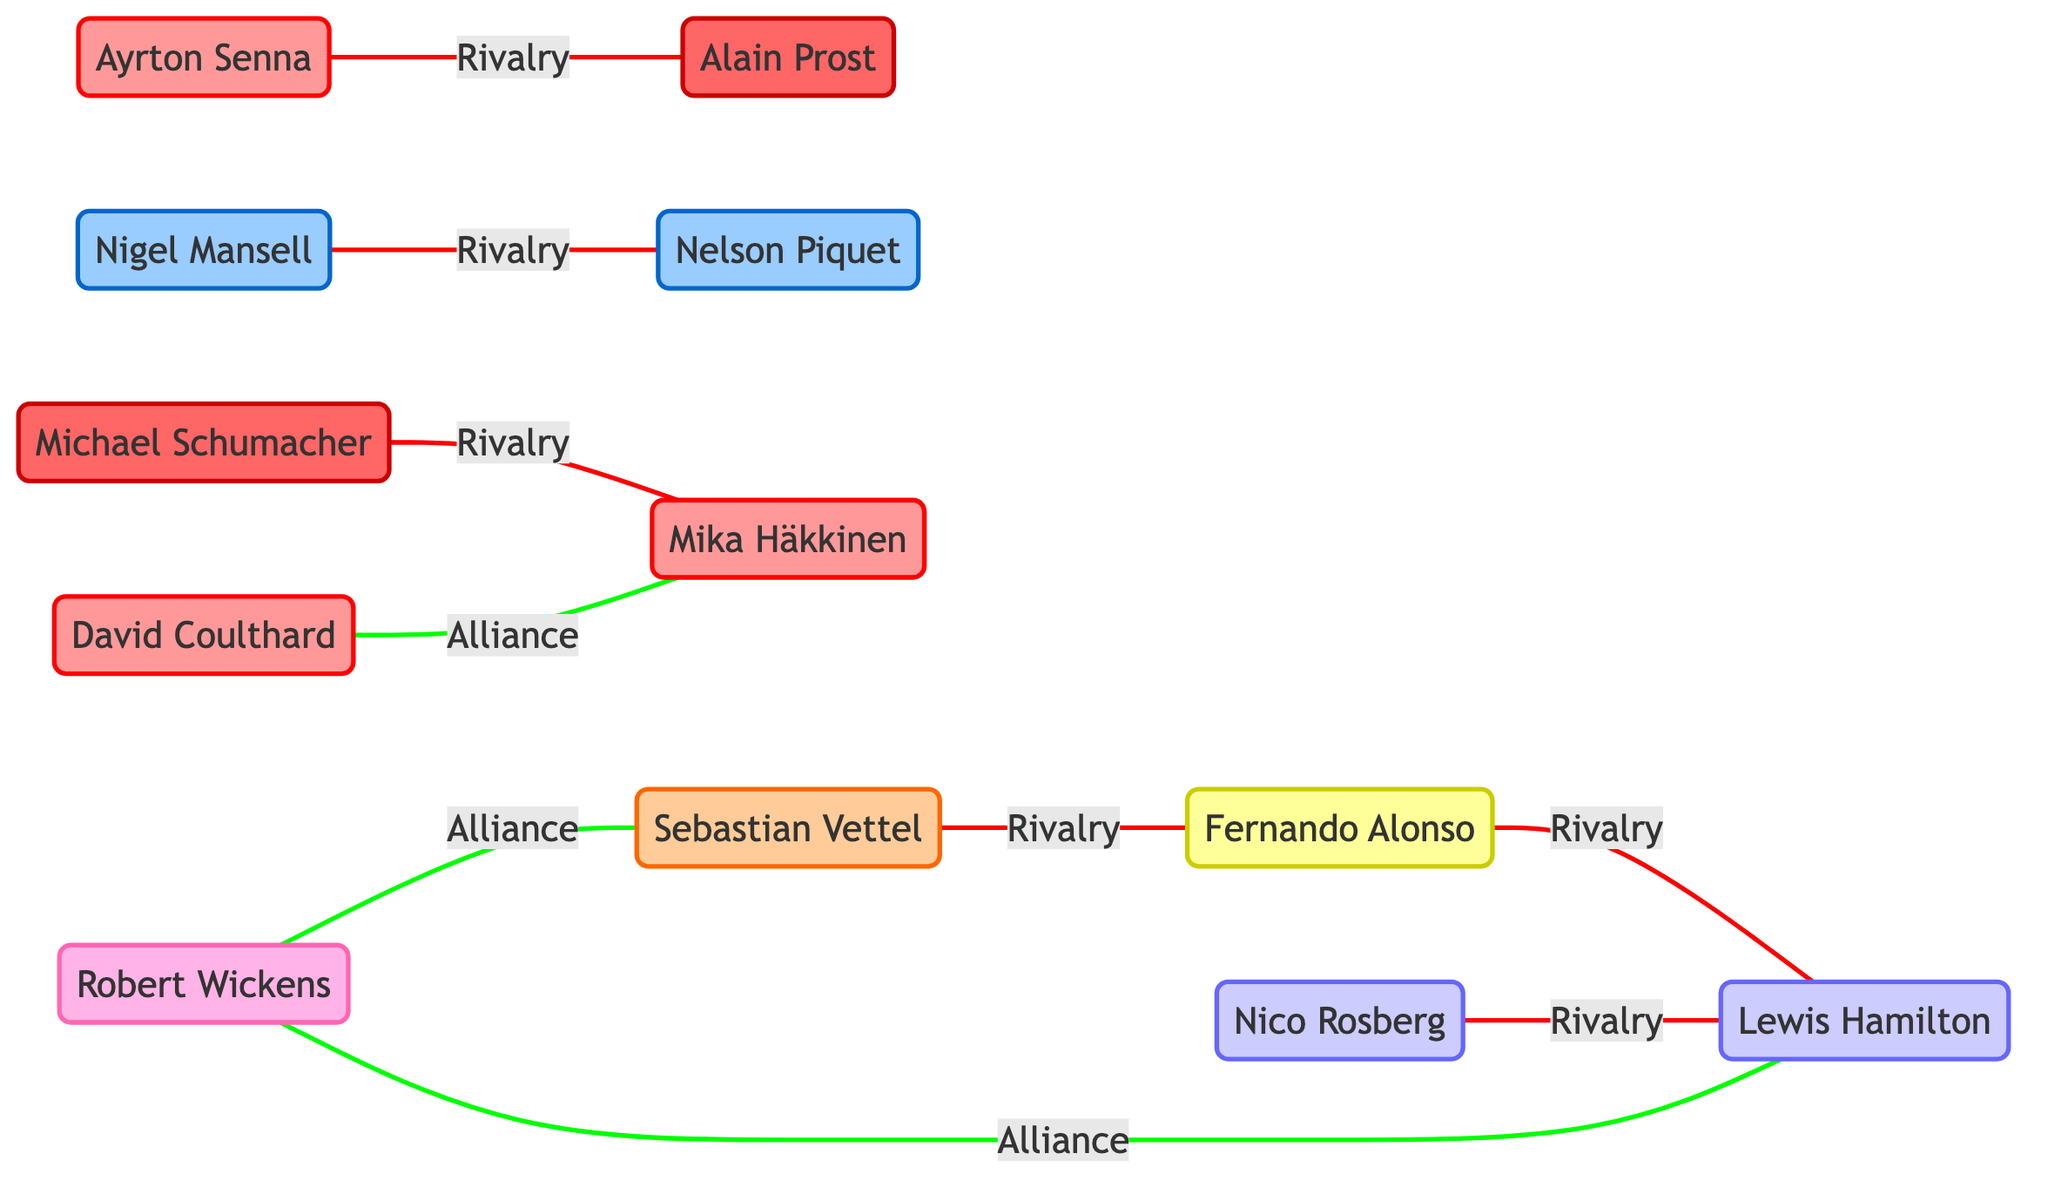What is the total number of drivers represented in the diagram? The diagram contains a list of nodes, each representing a driver. By counting the nodes provided in the data, we see there are a total of 12 drivers.
Answer: 12 Which two drivers have a rivalry according to the diagram? The relationships between drivers are indicated with arrows labeled as rivalries. By examining the links, we can identify that Ayrton Senna and Alain Prost have a rivalry.
Answer: Ayrton Senna and Alain Prost How many alliances are shown in the diagram? The alliances are represented by links labeled as "Alliance" in the diagram. By counting the number of such links present in the data, we find that there are three alliances: between David Coulthard & Mika Häkkinen, Robert Wickens & Lewis Hamilton, and Robert Wickens & Sebastian Vettel.
Answer: 3 Who is in alliance with Lewis Hamilton? In the diagram, the link indicating an alliance with Lewis Hamilton is between Robert Wickens and Lewis Hamilton; hence, Robert Wickens is his ally.
Answer: Robert Wickens Which driver has rivalries with both Fernando Alonso and Sebastian Vettel? To determine this, we look for the drivers linked to both Fernando Alonso and Sebastian Vettel with a "Rivalry." By checking the connections, we find that both Alonso and Vettel have a rivalry with Lewis Hamilton.
Answer: Lewis Hamilton How many drivers have only a rivalry shown in the diagram? We assume a driver has only a rivalry if they do not have any alliance connections. After analyzing the links, we see that five drivers (Alain Prost, Nigel Mansell, Michael Schumacher, Fernando Alonso, and Nico Rosberg) have only rivalries and no alliances.
Answer: 5 Which group does Robert Wickens belong to? The group affiliation of a driver is indicated alongside their name in the data. For Robert Wickens, it is stated as "DTM." Thus, he belongs to the DTM group.
Answer: DTM What type of relationship does David Coulthard have with Mika Häkkinen? In examining the link between David Coulthard and Mika Häkkinen in the diagram, we find it is labeled as "Alliance." Therefore, their relationship is that of an alliance.
Answer: Alliance 